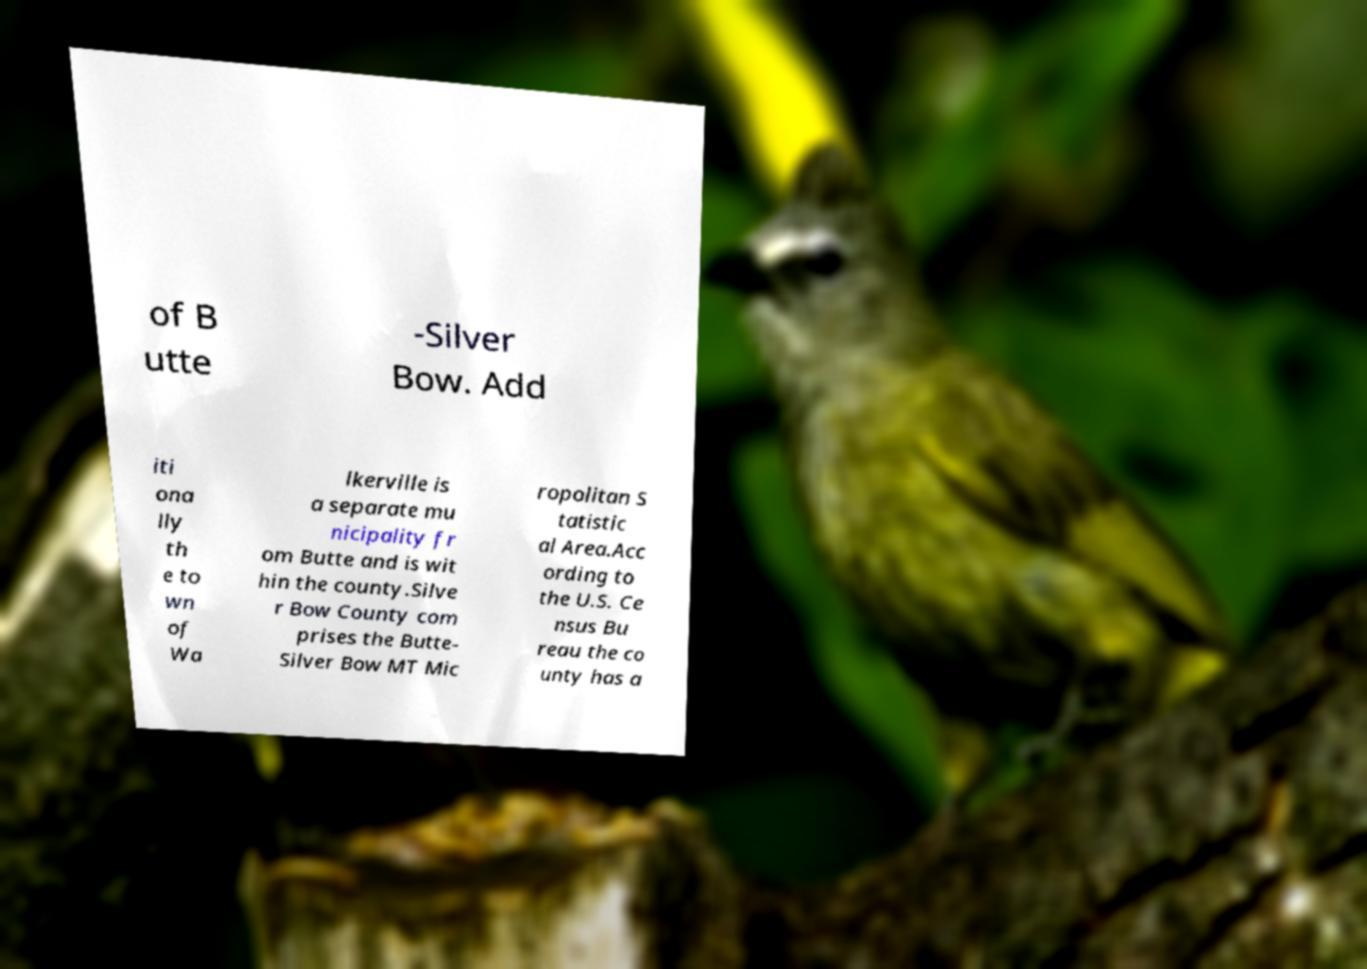Can you read and provide the text displayed in the image?This photo seems to have some interesting text. Can you extract and type it out for me? of B utte -Silver Bow. Add iti ona lly th e to wn of Wa lkerville is a separate mu nicipality fr om Butte and is wit hin the county.Silve r Bow County com prises the Butte- Silver Bow MT Mic ropolitan S tatistic al Area.Acc ording to the U.S. Ce nsus Bu reau the co unty has a 